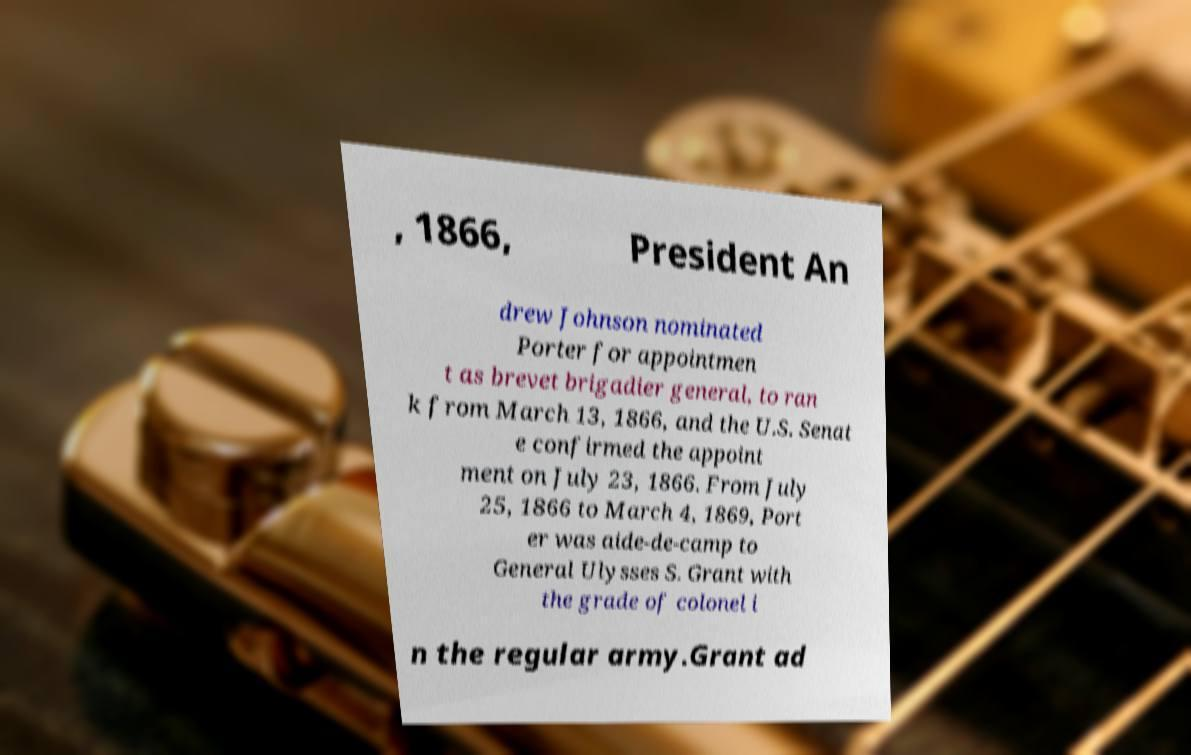What messages or text are displayed in this image? I need them in a readable, typed format. , 1866, President An drew Johnson nominated Porter for appointmen t as brevet brigadier general, to ran k from March 13, 1866, and the U.S. Senat e confirmed the appoint ment on July 23, 1866. From July 25, 1866 to March 4, 1869, Port er was aide-de-camp to General Ulysses S. Grant with the grade of colonel i n the regular army.Grant ad 